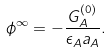Convert formula to latex. <formula><loc_0><loc_0><loc_500><loc_500>\phi ^ { \infty } = - \frac { G _ { A } ^ { ( 0 ) } } { \epsilon _ { A } a _ { A } } .</formula> 